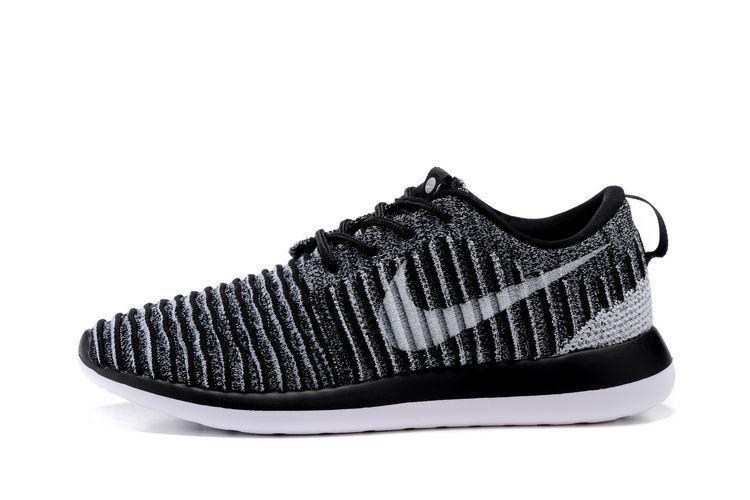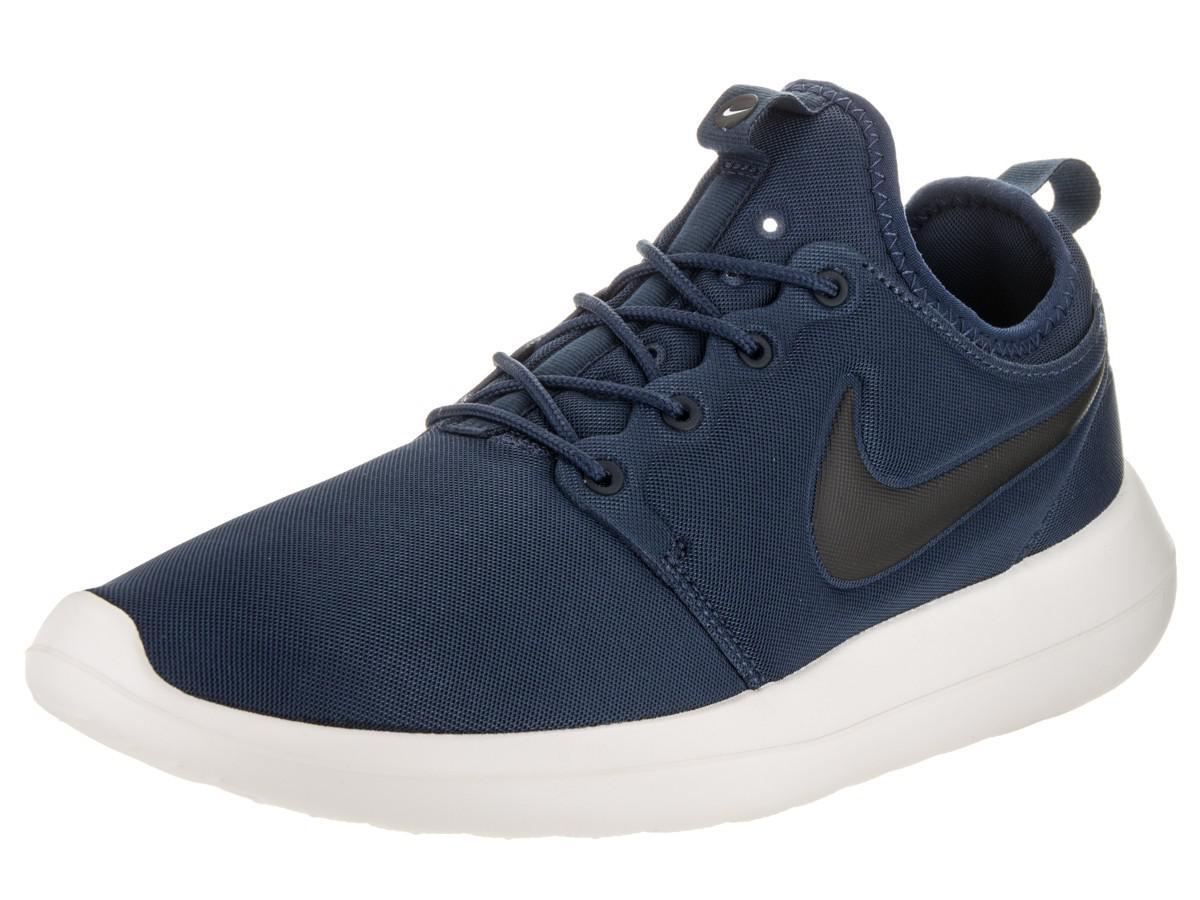The first image is the image on the left, the second image is the image on the right. Evaluate the accuracy of this statement regarding the images: "The combined images show exactly two left-facing sneakers.". Is it true? Answer yes or no. Yes. The first image is the image on the left, the second image is the image on the right. For the images displayed, is the sentence "There are two shoes, and one of them is striped, while the other is a plain color." factually correct? Answer yes or no. Yes. 